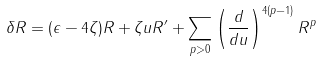Convert formula to latex. <formula><loc_0><loc_0><loc_500><loc_500>\delta R = ( \epsilon - 4 \zeta ) R + \zeta u R ^ { \prime } + \sum _ { p > 0 } \left ( \frac { d } { d u } \right ) ^ { 4 ( p - 1 ) } R ^ { p }</formula> 